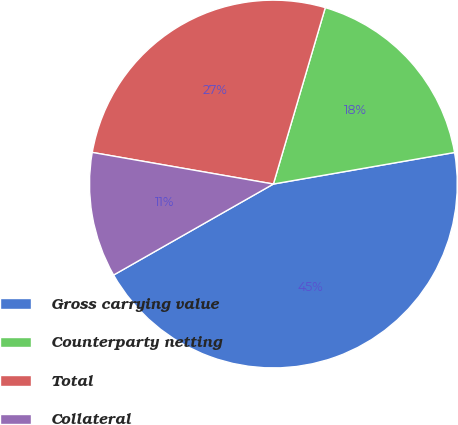<chart> <loc_0><loc_0><loc_500><loc_500><pie_chart><fcel>Gross carrying value<fcel>Counterparty netting<fcel>Total<fcel>Collateral<nl><fcel>44.5%<fcel>17.7%<fcel>26.8%<fcel>10.99%<nl></chart> 